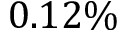<formula> <loc_0><loc_0><loc_500><loc_500>0 . 1 2 \%</formula> 